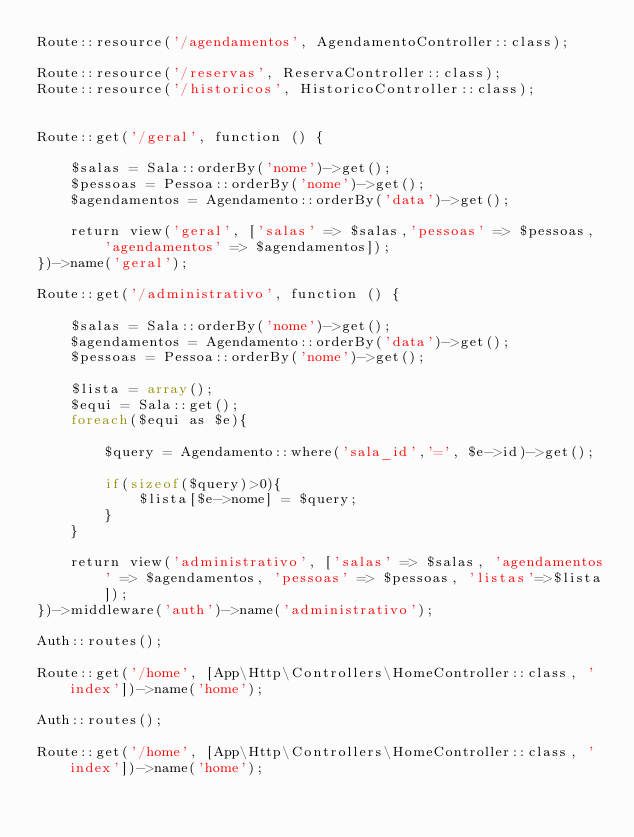Convert code to text. <code><loc_0><loc_0><loc_500><loc_500><_PHP_>Route::resource('/agendamentos', AgendamentoController::class);

Route::resource('/reservas', ReservaController::class);
Route::resource('/historicos', HistoricoController::class);


Route::get('/geral', function () {

    $salas = Sala::orderBy('nome')->get();
    $pessoas = Pessoa::orderBy('nome')->get();
    $agendamentos = Agendamento::orderBy('data')->get();

    return view('geral', ['salas' => $salas,'pessoas' => $pessoas, 'agendamentos' => $agendamentos]);
})->name('geral');

Route::get('/administrativo', function () {

    $salas = Sala::orderBy('nome')->get();
    $agendamentos = Agendamento::orderBy('data')->get();
    $pessoas = Pessoa::orderBy('nome')->get();

    $lista = array();
    $equi = Sala::get();
    foreach($equi as $e){

        $query = Agendamento::where('sala_id','=', $e->id)->get();

        if(sizeof($query)>0){
            $lista[$e->nome] = $query;
        } 
    }

    return view('administrativo', ['salas' => $salas, 'agendamentos' => $agendamentos, 'pessoas' => $pessoas, 'listas'=>$lista]);
})->middleware('auth')->name('administrativo');

Auth::routes();

Route::get('/home', [App\Http\Controllers\HomeController::class, 'index'])->name('home');

Auth::routes();

Route::get('/home', [App\Http\Controllers\HomeController::class, 'index'])->name('home');
</code> 